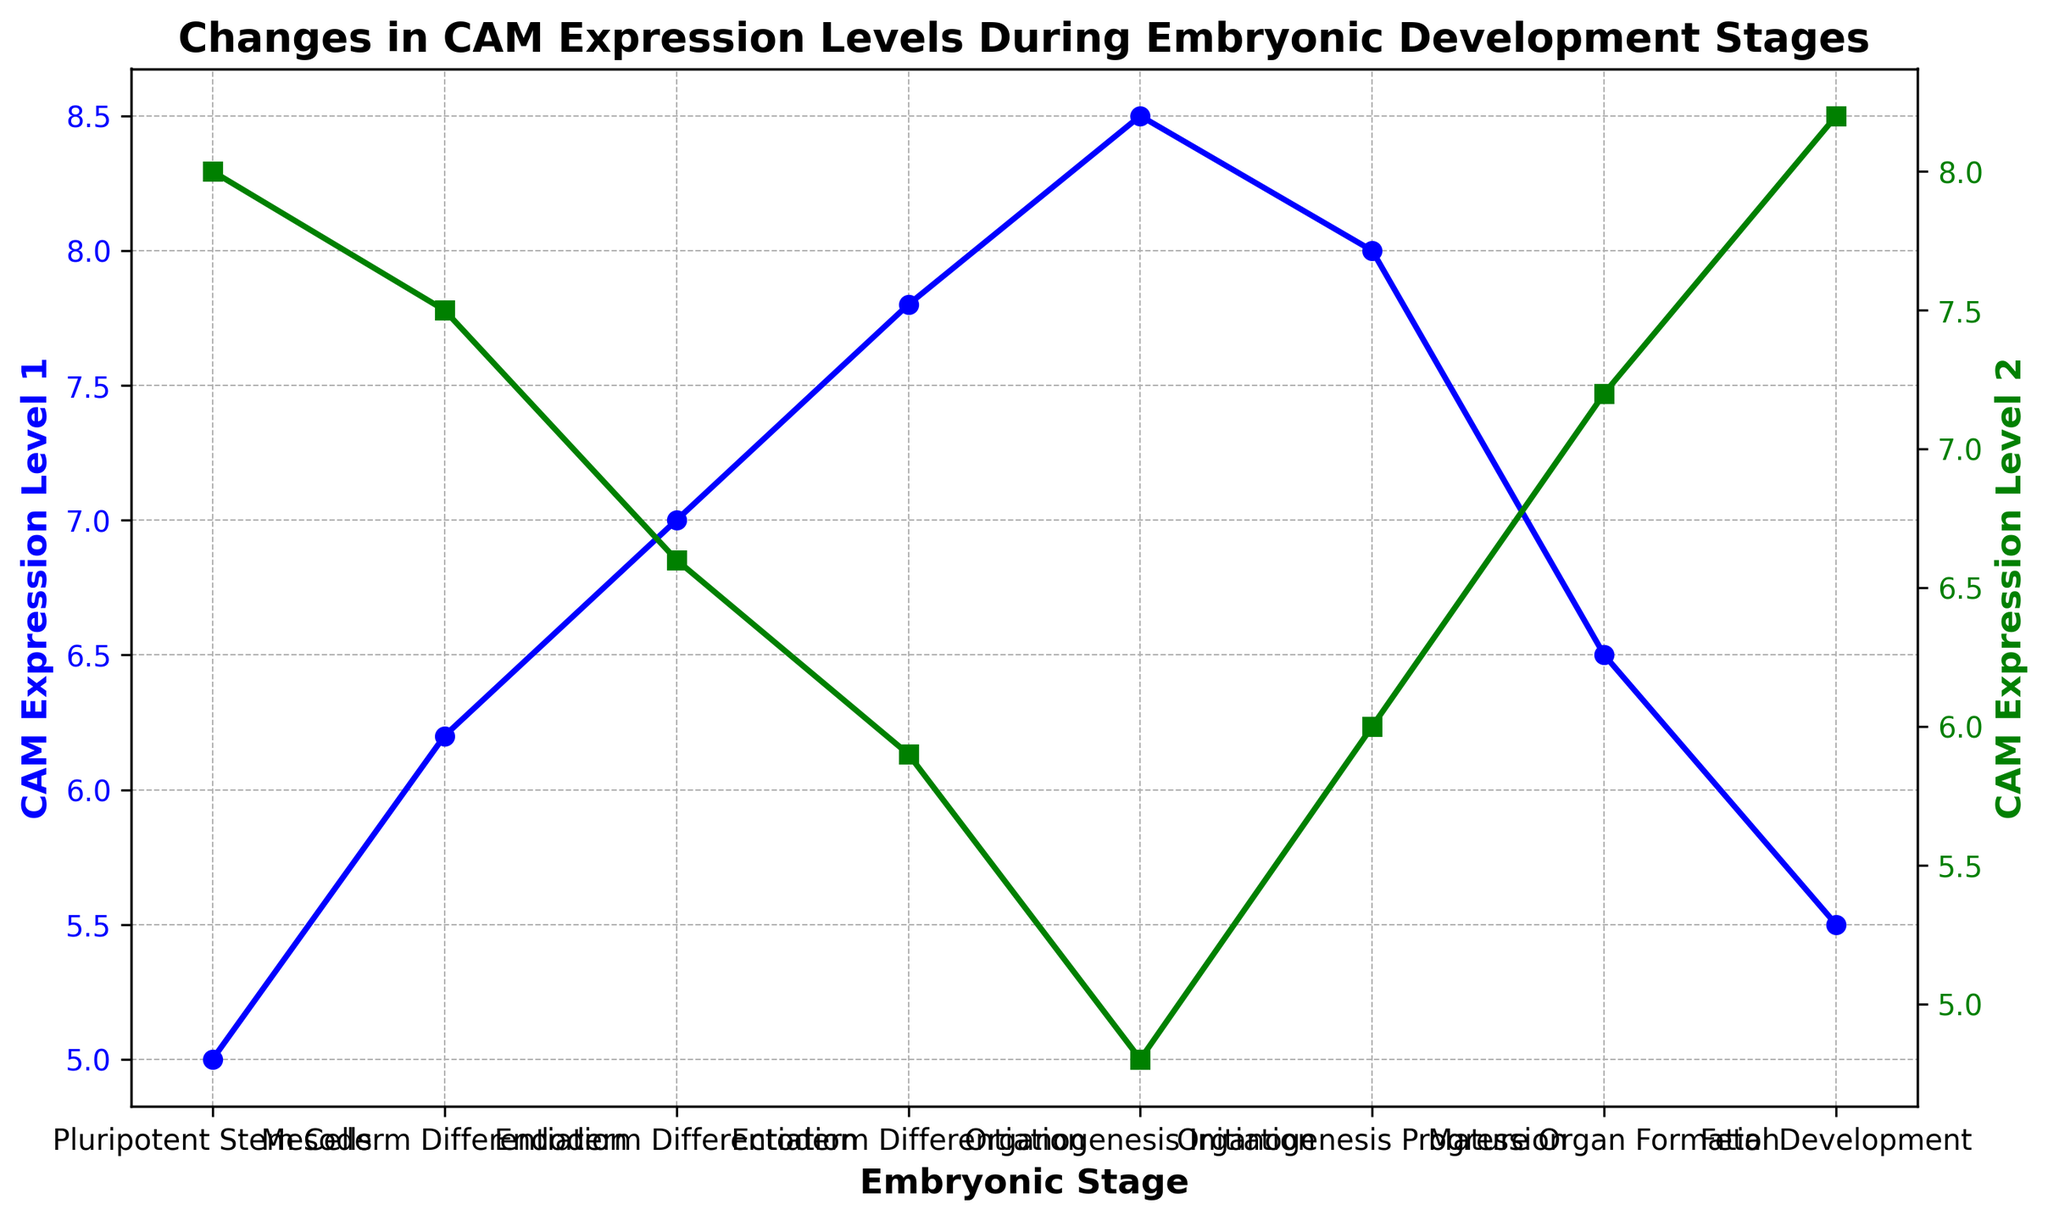What is the highest CAM Expression Level 1 across the different embryonic stages? To find the highest CAM Expression Level 1, look at the values associated with each embryonic stage and identify the maximum value. CAM Expression Level 1 peaks at Stage 5 (Organogenesis Initiation) with a level of 8.5.
Answer: 8.5 Which embryonic stage sees a transition from decreasing CAM Expression Level 2 to an increasing trend? From the figure, CAM Expression Level 2 decreases from Stage 1 to Stage 5, and then it starts to increase from Stage 5 to Stage 8. Therefore, the transition happens at Stage 5 (Organogenesis Initiation).
Answer: Stage 5 What are the CAM Expression Level 1 and CAM Expression Level 2 values at the Mature Organ Formation stage? Identify the Mature Organ Formation stage (Stage 7) and note the corresponding CAM Expression Level 1 and CAM Expression Level 2 values from the plot. At Stage 7, the values are 6.5 for CAM Expression Level 1 and 7.2 for CAM Expression Level 2.
Answer: 6.5, 7.2 In which stages is CAM Expression Level 1 higher than CAM Expression Level 2? Compare the values of CAM Expression Level 1 and CAM Expression Level 2 at each stage. CAM Expression Level 1 is higher than CAM Expression Level 2 in Stages 2, 3, 4, 5, and 6.
Answer: Stages 2, 3, 4, 5, 6 How much does CAM Expression Level 2 change from Pluripotent Stem Cells to Mesoderm Differentiation? Find the difference in CAM Expression Level 2 between Stage 1 (Pluripotent Stem Cells) and Stage 2 (Mesoderm Differentiation). The values are 8.0 and 7.5, respectively. The change is 8.0 - 7.5 = 0.5.
Answer: 0.5 At which stage do we observe the smallest difference between CAM Expression Level 1 and CAM Expression Level 2? Calculate the difference between CAM Expression Level 1 and CAM Expression Level 2 for each stage and identify the smallest difference. At Stage 6, the difference is smallest, with values of 8.0 for CAM Expression Level 1 and 6.0 for CAM Expression Level 2, resulting in a difference of 2.0.
Answer: Stage 6 What is the trend in CAM Expression Level 1 from Endoderm Differentiation to Organogenesis Initiation? Observe the trend in CAM Expression Level 1 values for Stages 3, 4, and 5, which correspond to Endoderm Differentiation, Ectoderm Differentiation, and Organogenesis Initiation, respectively. The values increase from 7.0 to 7.8, then to 8.5, showing an increasing trend.
Answer: Increasing How do CAM Expression Level 1 values at Stage 8 compare to Stage 1? Compare the value of CAM Expression Level 1 at Stage 8 (5.5) to that at Stage 1 (5.0). The expression level at Stage 8 is slightly higher than at Stage 1.
Answer: Higher On which stages do CAM Expression Levels 1 and 2 intersect or have the same approximate value? Find the stages where CAM Expression Level 1 and CAM Expression Level 2 values are closest or equal. They intersect or have similar values closely at Stage 6 with values 8.0 and 6.0 and Stage 7 with values 6.5 and 7.2, nearly intersecting.
Answer: Stage 6, Stage 7 